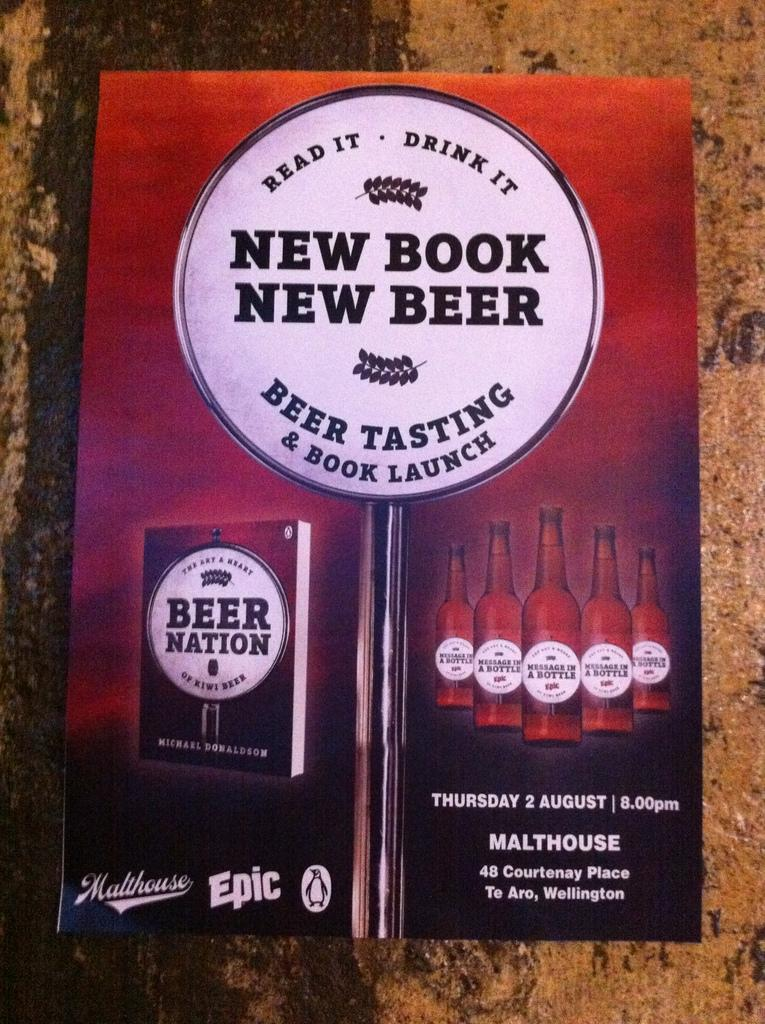<image>
Offer a succinct explanation of the picture presented. a book that has the phrase New Book New Beer on it 